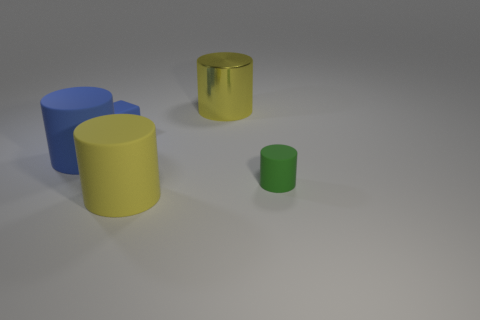Is the small blue object made of the same material as the tiny thing in front of the block?
Make the answer very short. Yes. Are there fewer metal objects on the right side of the yellow matte thing than big blue things that are on the right side of the tiny blue cube?
Offer a very short reply. No. How many other small green cylinders have the same material as the tiny green cylinder?
Provide a succinct answer. 0. There is a small blue rubber block in front of the shiny cylinder to the right of the small rubber block; are there any blue rubber cylinders on the right side of it?
Provide a succinct answer. No. How many cylinders are big blue things or tiny blue objects?
Make the answer very short. 1. There is a big blue object; does it have the same shape as the tiny rubber object that is behind the large blue rubber object?
Give a very brief answer. No. Are there fewer blue cylinders that are right of the metal thing than brown rubber cylinders?
Provide a succinct answer. No. Are there any small cylinders behind the tiny blue rubber object?
Offer a very short reply. No. Are there any other large objects of the same shape as the yellow rubber thing?
Your response must be concise. Yes. The other blue thing that is the same size as the shiny object is what shape?
Offer a terse response. Cylinder. 